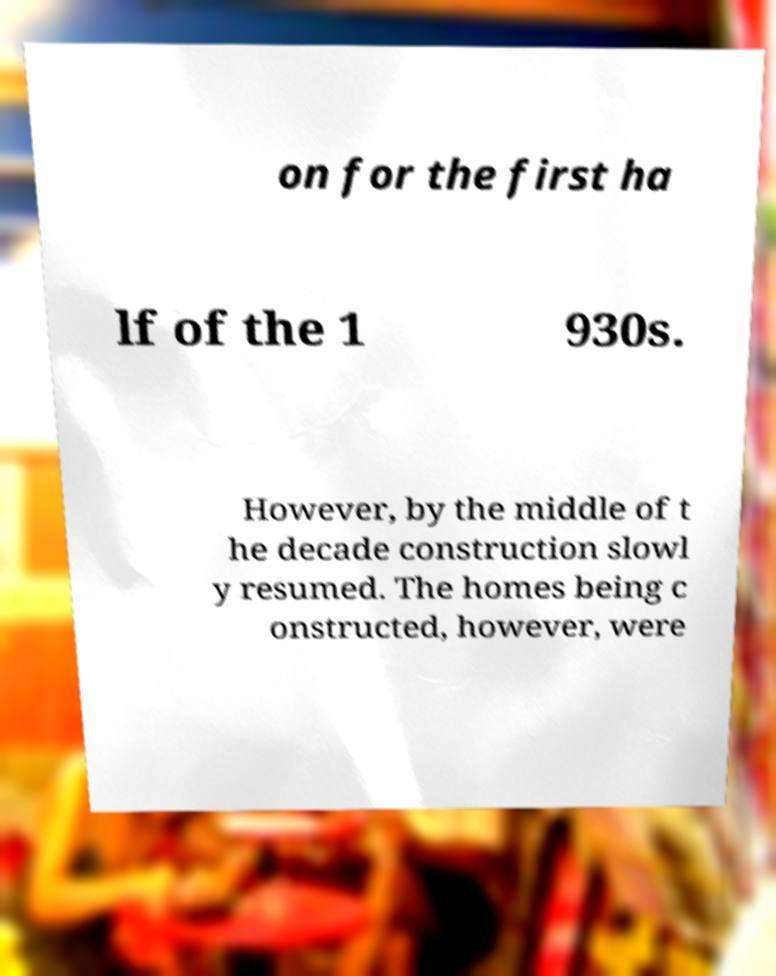There's text embedded in this image that I need extracted. Can you transcribe it verbatim? on for the first ha lf of the 1 930s. However, by the middle of t he decade construction slowl y resumed. The homes being c onstructed, however, were 